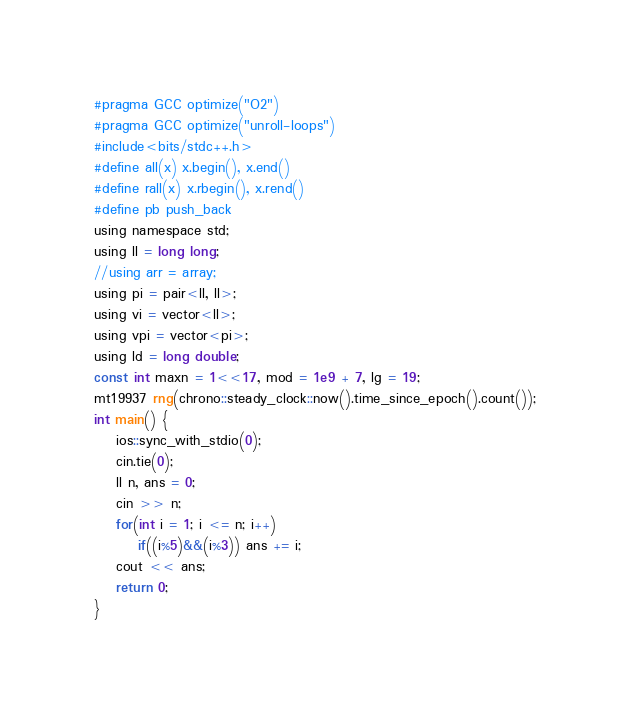<code> <loc_0><loc_0><loc_500><loc_500><_C_>#pragma GCC optimize("O2")
#pragma GCC optimize("unroll-loops")
#include<bits/stdc++.h>
#define all(x) x.begin(), x.end()
#define rall(x) x.rbegin(), x.rend()
#define pb push_back
using namespace std;
using ll = long long;
//using arr = array;
using pi = pair<ll, ll>;
using vi = vector<ll>;
using vpi = vector<pi>;
using ld = long double;
const int maxn = 1<<17, mod = 1e9 + 7, lg = 19;
mt19937 rng(chrono::steady_clock::now().time_since_epoch().count());
int main() {
	ios::sync_with_stdio(0);
	cin.tie(0);
	ll n, ans = 0;
	cin >> n;
	for(int i = 1; i <= n; i++)
		if((i%5)&&(i%3)) ans += i;
	cout << ans;
	return 0;
}
</code> 